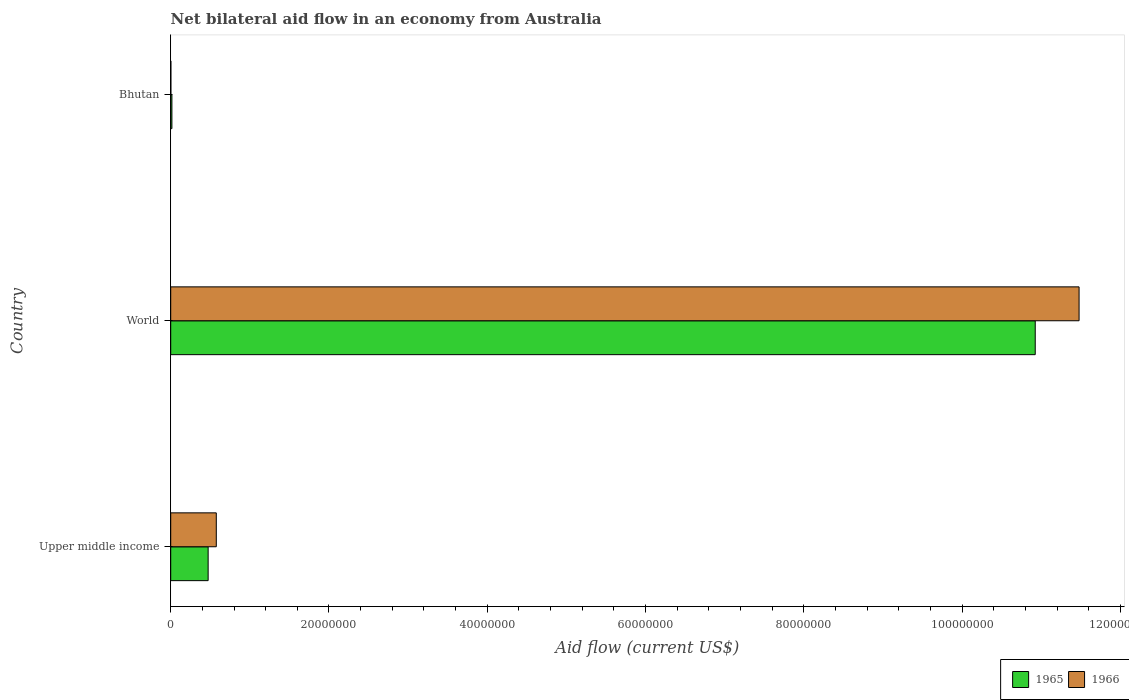How many different coloured bars are there?
Make the answer very short. 2. How many groups of bars are there?
Your answer should be very brief. 3. Are the number of bars per tick equal to the number of legend labels?
Give a very brief answer. Yes. Are the number of bars on each tick of the Y-axis equal?
Ensure brevity in your answer.  Yes. How many bars are there on the 3rd tick from the top?
Offer a very short reply. 2. How many bars are there on the 2nd tick from the bottom?
Provide a short and direct response. 2. What is the label of the 3rd group of bars from the top?
Provide a short and direct response. Upper middle income. In how many cases, is the number of bars for a given country not equal to the number of legend labels?
Offer a terse response. 0. Across all countries, what is the maximum net bilateral aid flow in 1965?
Your answer should be very brief. 1.09e+08. Across all countries, what is the minimum net bilateral aid flow in 1965?
Your answer should be very brief. 1.50e+05. In which country was the net bilateral aid flow in 1966 maximum?
Provide a succinct answer. World. In which country was the net bilateral aid flow in 1966 minimum?
Offer a very short reply. Bhutan. What is the total net bilateral aid flow in 1966 in the graph?
Ensure brevity in your answer.  1.21e+08. What is the difference between the net bilateral aid flow in 1966 in Upper middle income and that in World?
Keep it short and to the point. -1.09e+08. What is the difference between the net bilateral aid flow in 1966 in Bhutan and the net bilateral aid flow in 1965 in Upper middle income?
Provide a short and direct response. -4.71e+06. What is the average net bilateral aid flow in 1965 per country?
Keep it short and to the point. 3.80e+07. What is the difference between the net bilateral aid flow in 1965 and net bilateral aid flow in 1966 in Upper middle income?
Keep it short and to the point. -1.03e+06. In how many countries, is the net bilateral aid flow in 1965 greater than 44000000 US$?
Provide a succinct answer. 1. What is the ratio of the net bilateral aid flow in 1965 in Bhutan to that in Upper middle income?
Make the answer very short. 0.03. Is the net bilateral aid flow in 1966 in Bhutan less than that in Upper middle income?
Offer a terse response. Yes. Is the difference between the net bilateral aid flow in 1965 in Bhutan and Upper middle income greater than the difference between the net bilateral aid flow in 1966 in Bhutan and Upper middle income?
Offer a terse response. Yes. What is the difference between the highest and the second highest net bilateral aid flow in 1965?
Your answer should be very brief. 1.05e+08. What is the difference between the highest and the lowest net bilateral aid flow in 1966?
Your response must be concise. 1.15e+08. Is the sum of the net bilateral aid flow in 1965 in Upper middle income and World greater than the maximum net bilateral aid flow in 1966 across all countries?
Give a very brief answer. No. What does the 2nd bar from the top in Bhutan represents?
Provide a succinct answer. 1965. What does the 1st bar from the bottom in Upper middle income represents?
Offer a very short reply. 1965. How many bars are there?
Ensure brevity in your answer.  6. Are all the bars in the graph horizontal?
Make the answer very short. Yes. How many countries are there in the graph?
Provide a succinct answer. 3. Where does the legend appear in the graph?
Keep it short and to the point. Bottom right. How many legend labels are there?
Your response must be concise. 2. How are the legend labels stacked?
Your response must be concise. Horizontal. What is the title of the graph?
Give a very brief answer. Net bilateral aid flow in an economy from Australia. What is the label or title of the X-axis?
Your answer should be compact. Aid flow (current US$). What is the Aid flow (current US$) in 1965 in Upper middle income?
Your answer should be compact. 4.73e+06. What is the Aid flow (current US$) in 1966 in Upper middle income?
Ensure brevity in your answer.  5.76e+06. What is the Aid flow (current US$) of 1965 in World?
Offer a very short reply. 1.09e+08. What is the Aid flow (current US$) of 1966 in World?
Provide a succinct answer. 1.15e+08. What is the Aid flow (current US$) in 1966 in Bhutan?
Your answer should be very brief. 2.00e+04. Across all countries, what is the maximum Aid flow (current US$) of 1965?
Provide a short and direct response. 1.09e+08. Across all countries, what is the maximum Aid flow (current US$) in 1966?
Provide a succinct answer. 1.15e+08. Across all countries, what is the minimum Aid flow (current US$) in 1965?
Your response must be concise. 1.50e+05. What is the total Aid flow (current US$) of 1965 in the graph?
Offer a terse response. 1.14e+08. What is the total Aid flow (current US$) in 1966 in the graph?
Your answer should be compact. 1.21e+08. What is the difference between the Aid flow (current US$) in 1965 in Upper middle income and that in World?
Give a very brief answer. -1.05e+08. What is the difference between the Aid flow (current US$) of 1966 in Upper middle income and that in World?
Ensure brevity in your answer.  -1.09e+08. What is the difference between the Aid flow (current US$) of 1965 in Upper middle income and that in Bhutan?
Give a very brief answer. 4.58e+06. What is the difference between the Aid flow (current US$) of 1966 in Upper middle income and that in Bhutan?
Offer a very short reply. 5.74e+06. What is the difference between the Aid flow (current US$) in 1965 in World and that in Bhutan?
Your answer should be compact. 1.09e+08. What is the difference between the Aid flow (current US$) in 1966 in World and that in Bhutan?
Offer a very short reply. 1.15e+08. What is the difference between the Aid flow (current US$) in 1965 in Upper middle income and the Aid flow (current US$) in 1966 in World?
Provide a short and direct response. -1.10e+08. What is the difference between the Aid flow (current US$) of 1965 in Upper middle income and the Aid flow (current US$) of 1966 in Bhutan?
Give a very brief answer. 4.71e+06. What is the difference between the Aid flow (current US$) in 1965 in World and the Aid flow (current US$) in 1966 in Bhutan?
Your answer should be very brief. 1.09e+08. What is the average Aid flow (current US$) in 1965 per country?
Make the answer very short. 3.80e+07. What is the average Aid flow (current US$) of 1966 per country?
Offer a very short reply. 4.02e+07. What is the difference between the Aid flow (current US$) in 1965 and Aid flow (current US$) in 1966 in Upper middle income?
Give a very brief answer. -1.03e+06. What is the difference between the Aid flow (current US$) in 1965 and Aid flow (current US$) in 1966 in World?
Ensure brevity in your answer.  -5.54e+06. What is the ratio of the Aid flow (current US$) of 1965 in Upper middle income to that in World?
Make the answer very short. 0.04. What is the ratio of the Aid flow (current US$) of 1966 in Upper middle income to that in World?
Your answer should be compact. 0.05. What is the ratio of the Aid flow (current US$) in 1965 in Upper middle income to that in Bhutan?
Ensure brevity in your answer.  31.53. What is the ratio of the Aid flow (current US$) of 1966 in Upper middle income to that in Bhutan?
Offer a terse response. 288. What is the ratio of the Aid flow (current US$) of 1965 in World to that in Bhutan?
Offer a very short reply. 728.33. What is the ratio of the Aid flow (current US$) of 1966 in World to that in Bhutan?
Your answer should be compact. 5739.5. What is the difference between the highest and the second highest Aid flow (current US$) in 1965?
Offer a terse response. 1.05e+08. What is the difference between the highest and the second highest Aid flow (current US$) of 1966?
Offer a very short reply. 1.09e+08. What is the difference between the highest and the lowest Aid flow (current US$) in 1965?
Your answer should be very brief. 1.09e+08. What is the difference between the highest and the lowest Aid flow (current US$) of 1966?
Ensure brevity in your answer.  1.15e+08. 